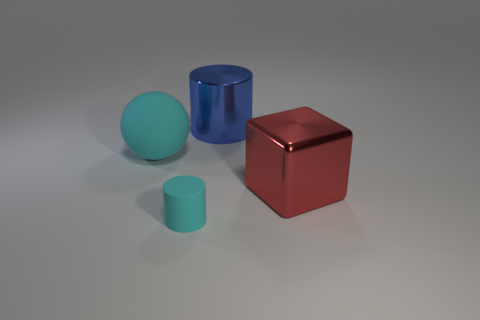Does the tiny thing have the same color as the big ball?
Offer a very short reply. Yes. What size is the object that is the same material as the large cylinder?
Ensure brevity in your answer.  Large. Is there anything else that has the same size as the cyan cylinder?
Give a very brief answer. No. What size is the cylinder behind the large object that is to the right of the big shiny cylinder?
Your answer should be very brief. Large. Do the large matte object that is to the left of the large red shiny block and the rubber object that is on the right side of the cyan rubber ball have the same color?
Your answer should be very brief. Yes. Are there any other things of the same color as the large sphere?
Provide a short and direct response. Yes. Do the large blue shiny thing and the tiny cyan object have the same shape?
Give a very brief answer. Yes. What is the size of the cyan matte cylinder?
Your answer should be very brief. Small. What color is the thing that is left of the large metallic block and on the right side of the tiny cyan thing?
Provide a short and direct response. Blue. Is the number of metallic cubes greater than the number of tiny green objects?
Offer a terse response. Yes. 